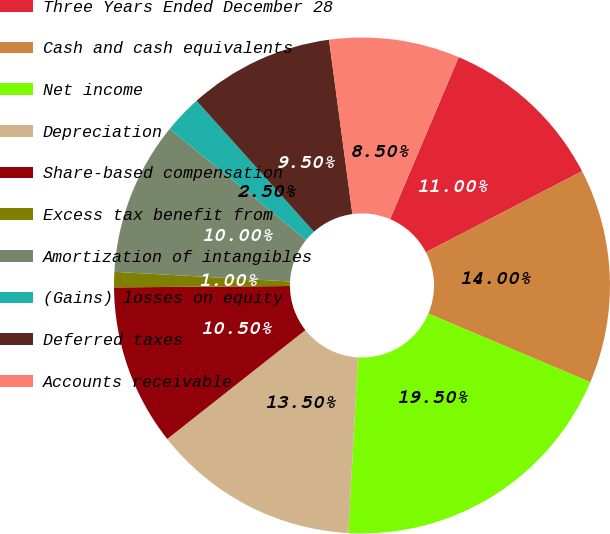Convert chart. <chart><loc_0><loc_0><loc_500><loc_500><pie_chart><fcel>Three Years Ended December 28<fcel>Cash and cash equivalents<fcel>Net income<fcel>Depreciation<fcel>Share-based compensation<fcel>Excess tax benefit from<fcel>Amortization of intangibles<fcel>(Gains) losses on equity<fcel>Deferred taxes<fcel>Accounts receivable<nl><fcel>11.0%<fcel>14.0%<fcel>19.5%<fcel>13.5%<fcel>10.5%<fcel>1.0%<fcel>10.0%<fcel>2.5%<fcel>9.5%<fcel>8.5%<nl></chart> 